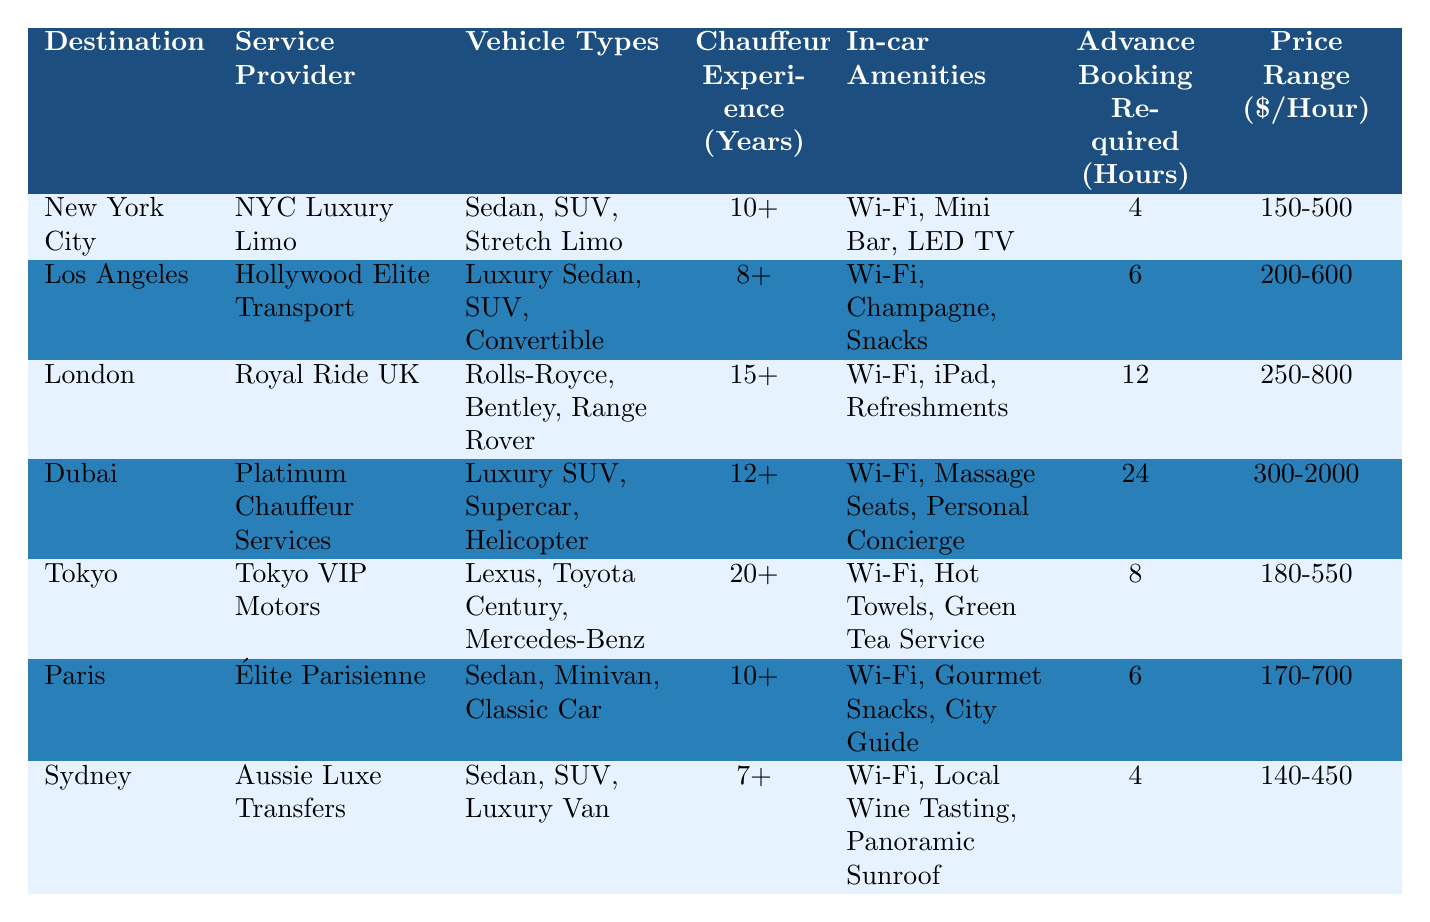What is the price range for VIP transportation services in Dubai? The table shows that the price range for VIP transportation services in Dubai is listed as 300-2000 dollars per hour.
Answer: 300-2000 How many years of chauffeur experience does the service provider in Tokyo have? Referring to the table, Tokyo VIP Motors lists chauffeur experience as 20+ years.
Answer: 20+ Which city requires the most advance booking hours? The table indicates that Dubai requires 24 hours of advance booking, which is more than any other city.
Answer: 24 hours What are the in-car amenities offered by the service provider in London? According to the table, Royal Ride UK in London offers Wi-Fi, iPad, and refreshments as in-car amenities.
Answer: Wi-Fi, iPad, Refreshments How does the chauffeur experience in Sydney compare to that in Los Angeles? The table states that Sydney has 7+ years of chauffeur experience while Los Angeles has 8+. Therefore, Los Angeles has slightly more experience than Sydney.
Answer: Los Angeles has more experience What is the average price range for all destinations listed? To find the average, sum the price ranges: (375 + 400 + 525 + 1150 + 365 + 435 + 295) = 3050, then divide by 7 destinations equals approximately 436.43.
Answer: 436.43 Does the service provider in Paris offer champagne as an in-car amenity? The table lists Paris's in-car amenities as Wi-Fi, gourmet snacks, and a city guide; it does not include champagne.
Answer: No Which city has the highest chauffeur experience and what is that experience? The table shows London has the highest chauffeur experience at 15+ years.
Answer: 15+ years If a client wants to travel to a destination requiring less than 6 hours of advance booking, which city options are there? New York City and Sydney require only 4 hours of advance booking, while Los Angeles and Paris require 6 hours. Thus, the options are New York City and Sydney.
Answer: New York City and Sydney What type of vehicle is available in Los Angeles but not in Sydney? The table shows that Los Angeles offers a convertible, which is not listed under Sydney's vehicle types.
Answer: Convertible 